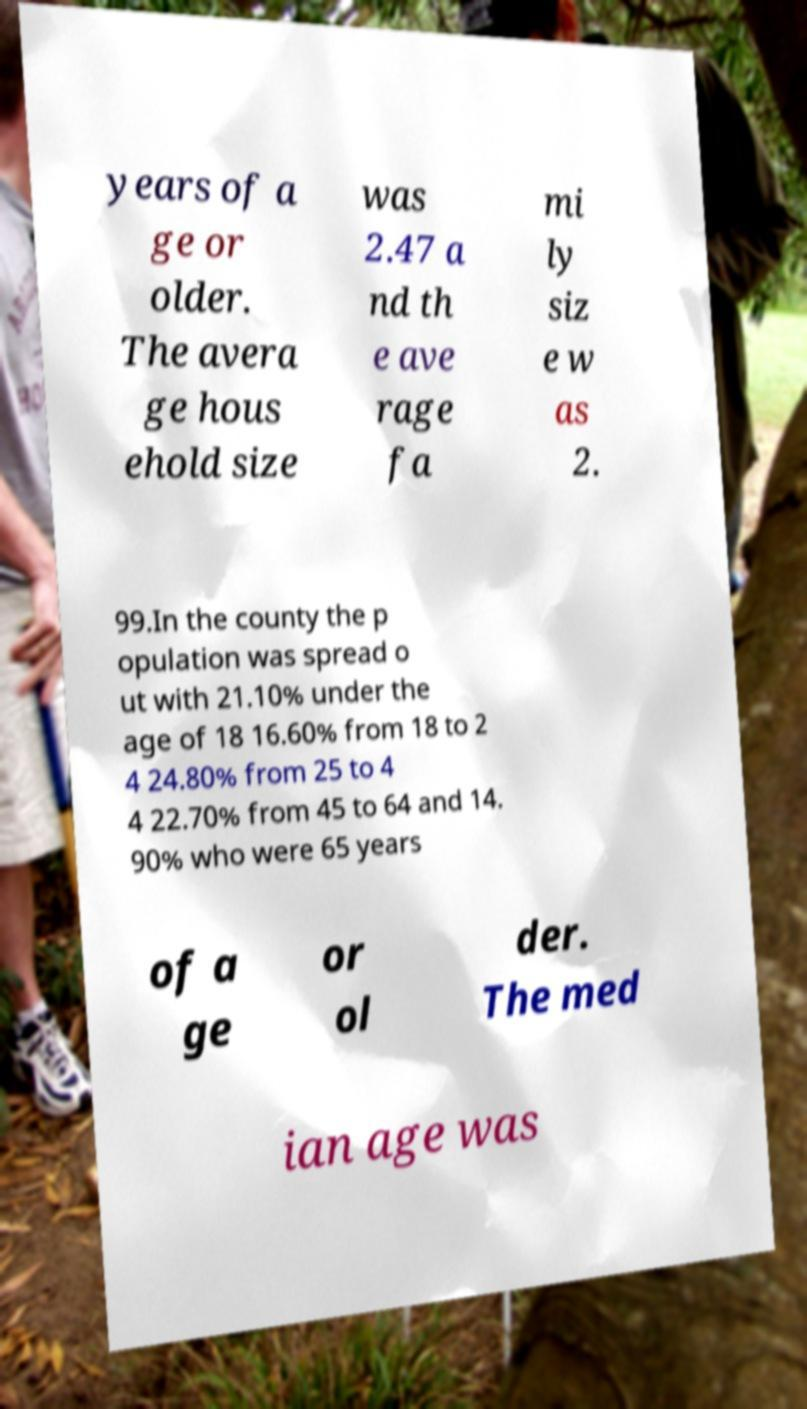Could you assist in decoding the text presented in this image and type it out clearly? years of a ge or older. The avera ge hous ehold size was 2.47 a nd th e ave rage fa mi ly siz e w as 2. 99.In the county the p opulation was spread o ut with 21.10% under the age of 18 16.60% from 18 to 2 4 24.80% from 25 to 4 4 22.70% from 45 to 64 and 14. 90% who were 65 years of a ge or ol der. The med ian age was 